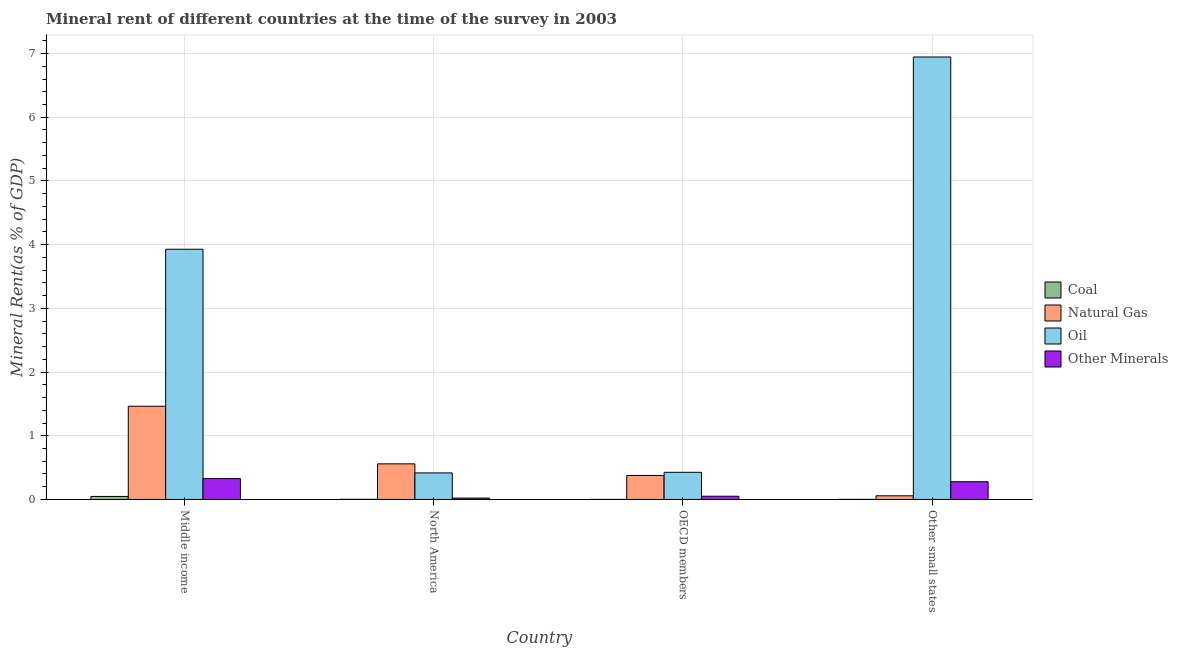How many different coloured bars are there?
Give a very brief answer. 4. How many bars are there on the 2nd tick from the left?
Provide a succinct answer. 4. What is the label of the 1st group of bars from the left?
Provide a short and direct response. Middle income. In how many cases, is the number of bars for a given country not equal to the number of legend labels?
Offer a very short reply. 0. What is the coal rent in North America?
Your answer should be compact. 0. Across all countries, what is the maximum  rent of other minerals?
Make the answer very short. 0.33. Across all countries, what is the minimum coal rent?
Ensure brevity in your answer.  0. In which country was the  rent of other minerals maximum?
Your answer should be compact. Middle income. In which country was the natural gas rent minimum?
Keep it short and to the point. Other small states. What is the total oil rent in the graph?
Keep it short and to the point. 11.72. What is the difference between the natural gas rent in Middle income and that in OECD members?
Offer a terse response. 1.09. What is the difference between the oil rent in Middle income and the  rent of other minerals in Other small states?
Ensure brevity in your answer.  3.65. What is the average  rent of other minerals per country?
Your response must be concise. 0.17. What is the difference between the coal rent and natural gas rent in Middle income?
Your answer should be compact. -1.42. What is the ratio of the coal rent in Middle income to that in North America?
Offer a terse response. 25.48. Is the natural gas rent in OECD members less than that in Other small states?
Keep it short and to the point. No. What is the difference between the highest and the second highest coal rent?
Your answer should be compact. 0.05. What is the difference between the highest and the lowest natural gas rent?
Provide a short and direct response. 1.41. What does the 2nd bar from the left in North America represents?
Ensure brevity in your answer.  Natural Gas. What does the 4th bar from the right in Other small states represents?
Provide a short and direct response. Coal. How many bars are there?
Provide a short and direct response. 16. How many countries are there in the graph?
Make the answer very short. 4. Does the graph contain grids?
Provide a short and direct response. Yes. How many legend labels are there?
Ensure brevity in your answer.  4. What is the title of the graph?
Ensure brevity in your answer.  Mineral rent of different countries at the time of the survey in 2003. What is the label or title of the X-axis?
Ensure brevity in your answer.  Country. What is the label or title of the Y-axis?
Your answer should be compact. Mineral Rent(as % of GDP). What is the Mineral Rent(as % of GDP) in Coal in Middle income?
Ensure brevity in your answer.  0.05. What is the Mineral Rent(as % of GDP) in Natural Gas in Middle income?
Keep it short and to the point. 1.46. What is the Mineral Rent(as % of GDP) of Oil in Middle income?
Ensure brevity in your answer.  3.93. What is the Mineral Rent(as % of GDP) in Other Minerals in Middle income?
Provide a short and direct response. 0.33. What is the Mineral Rent(as % of GDP) in Coal in North America?
Provide a short and direct response. 0. What is the Mineral Rent(as % of GDP) of Natural Gas in North America?
Your answer should be very brief. 0.56. What is the Mineral Rent(as % of GDP) of Oil in North America?
Your answer should be very brief. 0.42. What is the Mineral Rent(as % of GDP) of Other Minerals in North America?
Provide a short and direct response. 0.02. What is the Mineral Rent(as % of GDP) of Coal in OECD members?
Ensure brevity in your answer.  0. What is the Mineral Rent(as % of GDP) of Natural Gas in OECD members?
Your answer should be compact. 0.38. What is the Mineral Rent(as % of GDP) of Oil in OECD members?
Ensure brevity in your answer.  0.43. What is the Mineral Rent(as % of GDP) in Other Minerals in OECD members?
Ensure brevity in your answer.  0.05. What is the Mineral Rent(as % of GDP) of Coal in Other small states?
Your answer should be compact. 0. What is the Mineral Rent(as % of GDP) of Natural Gas in Other small states?
Offer a very short reply. 0.06. What is the Mineral Rent(as % of GDP) of Oil in Other small states?
Offer a very short reply. 6.95. What is the Mineral Rent(as % of GDP) of Other Minerals in Other small states?
Offer a very short reply. 0.28. Across all countries, what is the maximum Mineral Rent(as % of GDP) of Coal?
Make the answer very short. 0.05. Across all countries, what is the maximum Mineral Rent(as % of GDP) of Natural Gas?
Provide a succinct answer. 1.46. Across all countries, what is the maximum Mineral Rent(as % of GDP) in Oil?
Provide a succinct answer. 6.95. Across all countries, what is the maximum Mineral Rent(as % of GDP) of Other Minerals?
Give a very brief answer. 0.33. Across all countries, what is the minimum Mineral Rent(as % of GDP) in Coal?
Offer a very short reply. 0. Across all countries, what is the minimum Mineral Rent(as % of GDP) in Natural Gas?
Your answer should be compact. 0.06. Across all countries, what is the minimum Mineral Rent(as % of GDP) of Oil?
Keep it short and to the point. 0.42. Across all countries, what is the minimum Mineral Rent(as % of GDP) of Other Minerals?
Provide a short and direct response. 0.02. What is the total Mineral Rent(as % of GDP) in Coal in the graph?
Provide a succinct answer. 0.05. What is the total Mineral Rent(as % of GDP) in Natural Gas in the graph?
Your answer should be very brief. 2.46. What is the total Mineral Rent(as % of GDP) in Oil in the graph?
Give a very brief answer. 11.72. What is the total Mineral Rent(as % of GDP) of Other Minerals in the graph?
Ensure brevity in your answer.  0.68. What is the difference between the Mineral Rent(as % of GDP) in Coal in Middle income and that in North America?
Your response must be concise. 0.05. What is the difference between the Mineral Rent(as % of GDP) in Natural Gas in Middle income and that in North America?
Make the answer very short. 0.9. What is the difference between the Mineral Rent(as % of GDP) of Oil in Middle income and that in North America?
Give a very brief answer. 3.51. What is the difference between the Mineral Rent(as % of GDP) of Other Minerals in Middle income and that in North America?
Give a very brief answer. 0.31. What is the difference between the Mineral Rent(as % of GDP) of Coal in Middle income and that in OECD members?
Give a very brief answer. 0.05. What is the difference between the Mineral Rent(as % of GDP) of Natural Gas in Middle income and that in OECD members?
Make the answer very short. 1.09. What is the difference between the Mineral Rent(as % of GDP) in Oil in Middle income and that in OECD members?
Ensure brevity in your answer.  3.5. What is the difference between the Mineral Rent(as % of GDP) in Other Minerals in Middle income and that in OECD members?
Your answer should be very brief. 0.28. What is the difference between the Mineral Rent(as % of GDP) of Coal in Middle income and that in Other small states?
Make the answer very short. 0.05. What is the difference between the Mineral Rent(as % of GDP) of Natural Gas in Middle income and that in Other small states?
Offer a very short reply. 1.41. What is the difference between the Mineral Rent(as % of GDP) in Oil in Middle income and that in Other small states?
Offer a terse response. -3.02. What is the difference between the Mineral Rent(as % of GDP) of Other Minerals in Middle income and that in Other small states?
Your answer should be compact. 0.05. What is the difference between the Mineral Rent(as % of GDP) of Coal in North America and that in OECD members?
Provide a short and direct response. 0. What is the difference between the Mineral Rent(as % of GDP) in Natural Gas in North America and that in OECD members?
Make the answer very short. 0.18. What is the difference between the Mineral Rent(as % of GDP) in Oil in North America and that in OECD members?
Your answer should be compact. -0.01. What is the difference between the Mineral Rent(as % of GDP) in Other Minerals in North America and that in OECD members?
Keep it short and to the point. -0.03. What is the difference between the Mineral Rent(as % of GDP) of Coal in North America and that in Other small states?
Give a very brief answer. 0. What is the difference between the Mineral Rent(as % of GDP) in Natural Gas in North America and that in Other small states?
Make the answer very short. 0.5. What is the difference between the Mineral Rent(as % of GDP) of Oil in North America and that in Other small states?
Your answer should be very brief. -6.53. What is the difference between the Mineral Rent(as % of GDP) of Other Minerals in North America and that in Other small states?
Make the answer very short. -0.26. What is the difference between the Mineral Rent(as % of GDP) in Coal in OECD members and that in Other small states?
Offer a terse response. -0. What is the difference between the Mineral Rent(as % of GDP) in Natural Gas in OECD members and that in Other small states?
Offer a very short reply. 0.32. What is the difference between the Mineral Rent(as % of GDP) of Oil in OECD members and that in Other small states?
Your answer should be very brief. -6.52. What is the difference between the Mineral Rent(as % of GDP) of Other Minerals in OECD members and that in Other small states?
Offer a very short reply. -0.23. What is the difference between the Mineral Rent(as % of GDP) in Coal in Middle income and the Mineral Rent(as % of GDP) in Natural Gas in North America?
Your answer should be compact. -0.51. What is the difference between the Mineral Rent(as % of GDP) in Coal in Middle income and the Mineral Rent(as % of GDP) in Oil in North America?
Make the answer very short. -0.37. What is the difference between the Mineral Rent(as % of GDP) of Coal in Middle income and the Mineral Rent(as % of GDP) of Other Minerals in North America?
Your answer should be very brief. 0.03. What is the difference between the Mineral Rent(as % of GDP) of Natural Gas in Middle income and the Mineral Rent(as % of GDP) of Oil in North America?
Keep it short and to the point. 1.05. What is the difference between the Mineral Rent(as % of GDP) in Natural Gas in Middle income and the Mineral Rent(as % of GDP) in Other Minerals in North America?
Make the answer very short. 1.44. What is the difference between the Mineral Rent(as % of GDP) in Oil in Middle income and the Mineral Rent(as % of GDP) in Other Minerals in North America?
Your answer should be compact. 3.91. What is the difference between the Mineral Rent(as % of GDP) in Coal in Middle income and the Mineral Rent(as % of GDP) in Natural Gas in OECD members?
Provide a short and direct response. -0.33. What is the difference between the Mineral Rent(as % of GDP) of Coal in Middle income and the Mineral Rent(as % of GDP) of Oil in OECD members?
Offer a terse response. -0.38. What is the difference between the Mineral Rent(as % of GDP) in Coal in Middle income and the Mineral Rent(as % of GDP) in Other Minerals in OECD members?
Offer a very short reply. -0. What is the difference between the Mineral Rent(as % of GDP) of Natural Gas in Middle income and the Mineral Rent(as % of GDP) of Oil in OECD members?
Provide a succinct answer. 1.04. What is the difference between the Mineral Rent(as % of GDP) in Natural Gas in Middle income and the Mineral Rent(as % of GDP) in Other Minerals in OECD members?
Offer a terse response. 1.41. What is the difference between the Mineral Rent(as % of GDP) in Oil in Middle income and the Mineral Rent(as % of GDP) in Other Minerals in OECD members?
Offer a terse response. 3.88. What is the difference between the Mineral Rent(as % of GDP) in Coal in Middle income and the Mineral Rent(as % of GDP) in Natural Gas in Other small states?
Offer a terse response. -0.01. What is the difference between the Mineral Rent(as % of GDP) in Coal in Middle income and the Mineral Rent(as % of GDP) in Oil in Other small states?
Your answer should be very brief. -6.9. What is the difference between the Mineral Rent(as % of GDP) in Coal in Middle income and the Mineral Rent(as % of GDP) in Other Minerals in Other small states?
Provide a short and direct response. -0.23. What is the difference between the Mineral Rent(as % of GDP) in Natural Gas in Middle income and the Mineral Rent(as % of GDP) in Oil in Other small states?
Offer a very short reply. -5.48. What is the difference between the Mineral Rent(as % of GDP) in Natural Gas in Middle income and the Mineral Rent(as % of GDP) in Other Minerals in Other small states?
Your answer should be very brief. 1.18. What is the difference between the Mineral Rent(as % of GDP) of Oil in Middle income and the Mineral Rent(as % of GDP) of Other Minerals in Other small states?
Make the answer very short. 3.65. What is the difference between the Mineral Rent(as % of GDP) of Coal in North America and the Mineral Rent(as % of GDP) of Natural Gas in OECD members?
Offer a terse response. -0.37. What is the difference between the Mineral Rent(as % of GDP) of Coal in North America and the Mineral Rent(as % of GDP) of Oil in OECD members?
Offer a very short reply. -0.42. What is the difference between the Mineral Rent(as % of GDP) in Coal in North America and the Mineral Rent(as % of GDP) in Other Minerals in OECD members?
Your response must be concise. -0.05. What is the difference between the Mineral Rent(as % of GDP) of Natural Gas in North America and the Mineral Rent(as % of GDP) of Oil in OECD members?
Give a very brief answer. 0.13. What is the difference between the Mineral Rent(as % of GDP) of Natural Gas in North America and the Mineral Rent(as % of GDP) of Other Minerals in OECD members?
Keep it short and to the point. 0.51. What is the difference between the Mineral Rent(as % of GDP) of Oil in North America and the Mineral Rent(as % of GDP) of Other Minerals in OECD members?
Provide a short and direct response. 0.37. What is the difference between the Mineral Rent(as % of GDP) in Coal in North America and the Mineral Rent(as % of GDP) in Natural Gas in Other small states?
Ensure brevity in your answer.  -0.06. What is the difference between the Mineral Rent(as % of GDP) in Coal in North America and the Mineral Rent(as % of GDP) in Oil in Other small states?
Provide a short and direct response. -6.94. What is the difference between the Mineral Rent(as % of GDP) in Coal in North America and the Mineral Rent(as % of GDP) in Other Minerals in Other small states?
Make the answer very short. -0.28. What is the difference between the Mineral Rent(as % of GDP) of Natural Gas in North America and the Mineral Rent(as % of GDP) of Oil in Other small states?
Make the answer very short. -6.39. What is the difference between the Mineral Rent(as % of GDP) of Natural Gas in North America and the Mineral Rent(as % of GDP) of Other Minerals in Other small states?
Keep it short and to the point. 0.28. What is the difference between the Mineral Rent(as % of GDP) in Oil in North America and the Mineral Rent(as % of GDP) in Other Minerals in Other small states?
Provide a succinct answer. 0.14. What is the difference between the Mineral Rent(as % of GDP) of Coal in OECD members and the Mineral Rent(as % of GDP) of Natural Gas in Other small states?
Offer a terse response. -0.06. What is the difference between the Mineral Rent(as % of GDP) of Coal in OECD members and the Mineral Rent(as % of GDP) of Oil in Other small states?
Ensure brevity in your answer.  -6.94. What is the difference between the Mineral Rent(as % of GDP) in Coal in OECD members and the Mineral Rent(as % of GDP) in Other Minerals in Other small states?
Your answer should be compact. -0.28. What is the difference between the Mineral Rent(as % of GDP) in Natural Gas in OECD members and the Mineral Rent(as % of GDP) in Oil in Other small states?
Provide a succinct answer. -6.57. What is the difference between the Mineral Rent(as % of GDP) of Natural Gas in OECD members and the Mineral Rent(as % of GDP) of Other Minerals in Other small states?
Your answer should be very brief. 0.1. What is the difference between the Mineral Rent(as % of GDP) of Oil in OECD members and the Mineral Rent(as % of GDP) of Other Minerals in Other small states?
Keep it short and to the point. 0.15. What is the average Mineral Rent(as % of GDP) of Coal per country?
Give a very brief answer. 0.01. What is the average Mineral Rent(as % of GDP) of Natural Gas per country?
Offer a terse response. 0.61. What is the average Mineral Rent(as % of GDP) in Oil per country?
Give a very brief answer. 2.93. What is the average Mineral Rent(as % of GDP) of Other Minerals per country?
Your response must be concise. 0.17. What is the difference between the Mineral Rent(as % of GDP) in Coal and Mineral Rent(as % of GDP) in Natural Gas in Middle income?
Provide a short and direct response. -1.42. What is the difference between the Mineral Rent(as % of GDP) in Coal and Mineral Rent(as % of GDP) in Oil in Middle income?
Provide a short and direct response. -3.88. What is the difference between the Mineral Rent(as % of GDP) in Coal and Mineral Rent(as % of GDP) in Other Minerals in Middle income?
Ensure brevity in your answer.  -0.28. What is the difference between the Mineral Rent(as % of GDP) in Natural Gas and Mineral Rent(as % of GDP) in Oil in Middle income?
Give a very brief answer. -2.46. What is the difference between the Mineral Rent(as % of GDP) of Natural Gas and Mineral Rent(as % of GDP) of Other Minerals in Middle income?
Ensure brevity in your answer.  1.14. What is the difference between the Mineral Rent(as % of GDP) in Oil and Mineral Rent(as % of GDP) in Other Minerals in Middle income?
Provide a succinct answer. 3.6. What is the difference between the Mineral Rent(as % of GDP) in Coal and Mineral Rent(as % of GDP) in Natural Gas in North America?
Offer a terse response. -0.56. What is the difference between the Mineral Rent(as % of GDP) in Coal and Mineral Rent(as % of GDP) in Oil in North America?
Offer a terse response. -0.41. What is the difference between the Mineral Rent(as % of GDP) of Coal and Mineral Rent(as % of GDP) of Other Minerals in North America?
Ensure brevity in your answer.  -0.02. What is the difference between the Mineral Rent(as % of GDP) of Natural Gas and Mineral Rent(as % of GDP) of Oil in North America?
Make the answer very short. 0.14. What is the difference between the Mineral Rent(as % of GDP) in Natural Gas and Mineral Rent(as % of GDP) in Other Minerals in North America?
Offer a very short reply. 0.54. What is the difference between the Mineral Rent(as % of GDP) in Oil and Mineral Rent(as % of GDP) in Other Minerals in North America?
Give a very brief answer. 0.4. What is the difference between the Mineral Rent(as % of GDP) in Coal and Mineral Rent(as % of GDP) in Natural Gas in OECD members?
Ensure brevity in your answer.  -0.38. What is the difference between the Mineral Rent(as % of GDP) of Coal and Mineral Rent(as % of GDP) of Oil in OECD members?
Ensure brevity in your answer.  -0.43. What is the difference between the Mineral Rent(as % of GDP) in Coal and Mineral Rent(as % of GDP) in Other Minerals in OECD members?
Your answer should be compact. -0.05. What is the difference between the Mineral Rent(as % of GDP) of Natural Gas and Mineral Rent(as % of GDP) of Oil in OECD members?
Your answer should be very brief. -0.05. What is the difference between the Mineral Rent(as % of GDP) of Natural Gas and Mineral Rent(as % of GDP) of Other Minerals in OECD members?
Your response must be concise. 0.33. What is the difference between the Mineral Rent(as % of GDP) in Oil and Mineral Rent(as % of GDP) in Other Minerals in OECD members?
Your answer should be compact. 0.38. What is the difference between the Mineral Rent(as % of GDP) in Coal and Mineral Rent(as % of GDP) in Natural Gas in Other small states?
Make the answer very short. -0.06. What is the difference between the Mineral Rent(as % of GDP) of Coal and Mineral Rent(as % of GDP) of Oil in Other small states?
Make the answer very short. -6.94. What is the difference between the Mineral Rent(as % of GDP) of Coal and Mineral Rent(as % of GDP) of Other Minerals in Other small states?
Your response must be concise. -0.28. What is the difference between the Mineral Rent(as % of GDP) of Natural Gas and Mineral Rent(as % of GDP) of Oil in Other small states?
Provide a succinct answer. -6.89. What is the difference between the Mineral Rent(as % of GDP) of Natural Gas and Mineral Rent(as % of GDP) of Other Minerals in Other small states?
Keep it short and to the point. -0.22. What is the difference between the Mineral Rent(as % of GDP) in Oil and Mineral Rent(as % of GDP) in Other Minerals in Other small states?
Provide a short and direct response. 6.67. What is the ratio of the Mineral Rent(as % of GDP) of Coal in Middle income to that in North America?
Your response must be concise. 25.48. What is the ratio of the Mineral Rent(as % of GDP) in Natural Gas in Middle income to that in North America?
Provide a short and direct response. 2.62. What is the ratio of the Mineral Rent(as % of GDP) of Oil in Middle income to that in North America?
Make the answer very short. 9.43. What is the ratio of the Mineral Rent(as % of GDP) in Other Minerals in Middle income to that in North America?
Ensure brevity in your answer.  15.22. What is the ratio of the Mineral Rent(as % of GDP) of Coal in Middle income to that in OECD members?
Provide a succinct answer. 51.24. What is the ratio of the Mineral Rent(as % of GDP) of Natural Gas in Middle income to that in OECD members?
Keep it short and to the point. 3.89. What is the ratio of the Mineral Rent(as % of GDP) in Oil in Middle income to that in OECD members?
Your response must be concise. 9.22. What is the ratio of the Mineral Rent(as % of GDP) of Other Minerals in Middle income to that in OECD members?
Provide a short and direct response. 6.48. What is the ratio of the Mineral Rent(as % of GDP) in Coal in Middle income to that in Other small states?
Keep it short and to the point. 40.51. What is the ratio of the Mineral Rent(as % of GDP) of Natural Gas in Middle income to that in Other small states?
Make the answer very short. 25.42. What is the ratio of the Mineral Rent(as % of GDP) of Oil in Middle income to that in Other small states?
Keep it short and to the point. 0.57. What is the ratio of the Mineral Rent(as % of GDP) of Other Minerals in Middle income to that in Other small states?
Your response must be concise. 1.18. What is the ratio of the Mineral Rent(as % of GDP) in Coal in North America to that in OECD members?
Keep it short and to the point. 2.01. What is the ratio of the Mineral Rent(as % of GDP) in Natural Gas in North America to that in OECD members?
Offer a terse response. 1.48. What is the ratio of the Mineral Rent(as % of GDP) in Oil in North America to that in OECD members?
Make the answer very short. 0.98. What is the ratio of the Mineral Rent(as % of GDP) in Other Minerals in North America to that in OECD members?
Ensure brevity in your answer.  0.43. What is the ratio of the Mineral Rent(as % of GDP) in Coal in North America to that in Other small states?
Ensure brevity in your answer.  1.59. What is the ratio of the Mineral Rent(as % of GDP) in Natural Gas in North America to that in Other small states?
Give a very brief answer. 9.71. What is the ratio of the Mineral Rent(as % of GDP) in Oil in North America to that in Other small states?
Provide a succinct answer. 0.06. What is the ratio of the Mineral Rent(as % of GDP) in Other Minerals in North America to that in Other small states?
Your answer should be very brief. 0.08. What is the ratio of the Mineral Rent(as % of GDP) in Coal in OECD members to that in Other small states?
Your answer should be compact. 0.79. What is the ratio of the Mineral Rent(as % of GDP) of Natural Gas in OECD members to that in Other small states?
Provide a succinct answer. 6.54. What is the ratio of the Mineral Rent(as % of GDP) of Oil in OECD members to that in Other small states?
Make the answer very short. 0.06. What is the ratio of the Mineral Rent(as % of GDP) of Other Minerals in OECD members to that in Other small states?
Give a very brief answer. 0.18. What is the difference between the highest and the second highest Mineral Rent(as % of GDP) of Coal?
Your answer should be compact. 0.05. What is the difference between the highest and the second highest Mineral Rent(as % of GDP) in Natural Gas?
Provide a succinct answer. 0.9. What is the difference between the highest and the second highest Mineral Rent(as % of GDP) in Oil?
Make the answer very short. 3.02. What is the difference between the highest and the second highest Mineral Rent(as % of GDP) in Other Minerals?
Provide a succinct answer. 0.05. What is the difference between the highest and the lowest Mineral Rent(as % of GDP) of Coal?
Ensure brevity in your answer.  0.05. What is the difference between the highest and the lowest Mineral Rent(as % of GDP) of Natural Gas?
Make the answer very short. 1.41. What is the difference between the highest and the lowest Mineral Rent(as % of GDP) of Oil?
Keep it short and to the point. 6.53. What is the difference between the highest and the lowest Mineral Rent(as % of GDP) in Other Minerals?
Offer a terse response. 0.31. 